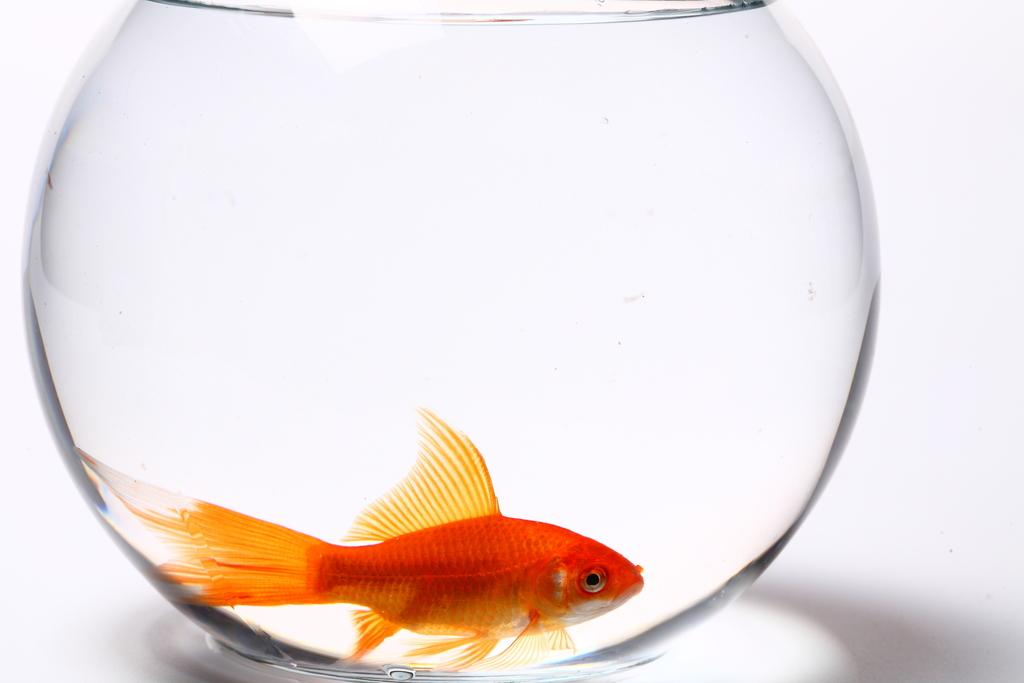What type of container is present in the image? There is an aquarium pot in the image. What is inside the aquarium pot? The aquarium pot contains water. What can be found swimming in the water? There is a fish in the water. What color is the fish? The fish is orange in color. How many women are standing next to the mailbox in the image? There is no mailbox or women present in the image. 